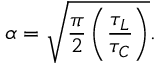Convert formula to latex. <formula><loc_0><loc_0><loc_500><loc_500>\alpha = \sqrt { \frac { \pi } { 2 } \left ( \frac { \tau _ { L } } { \tau _ { C } } \right ) } .</formula> 